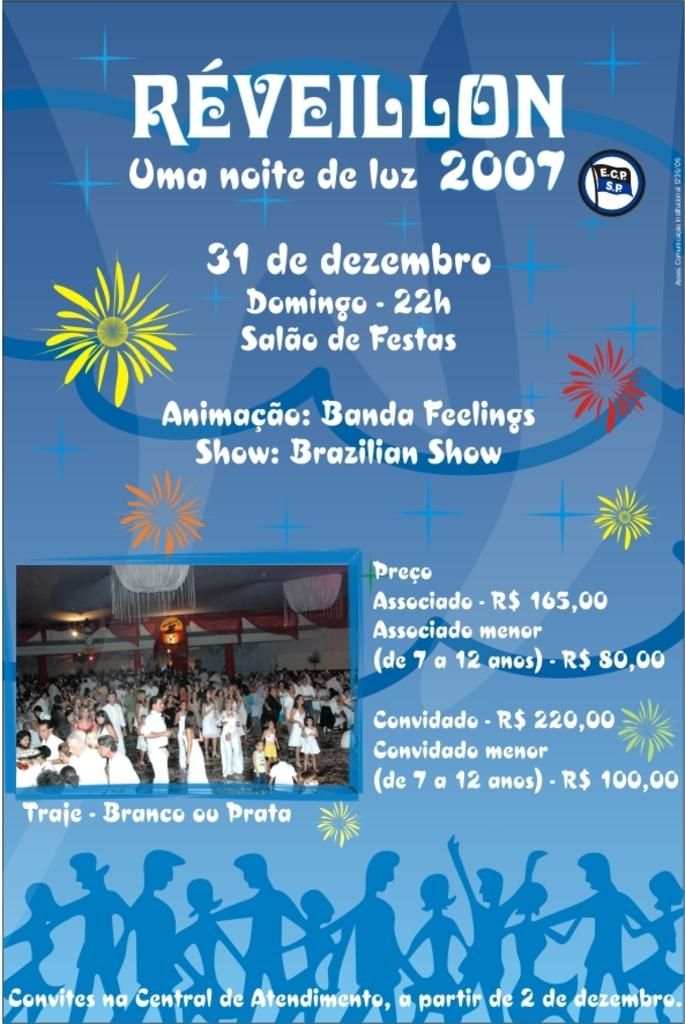Provide a one-sentence caption for the provided image. A poster with a picture and some text that is titled Reveillon. 